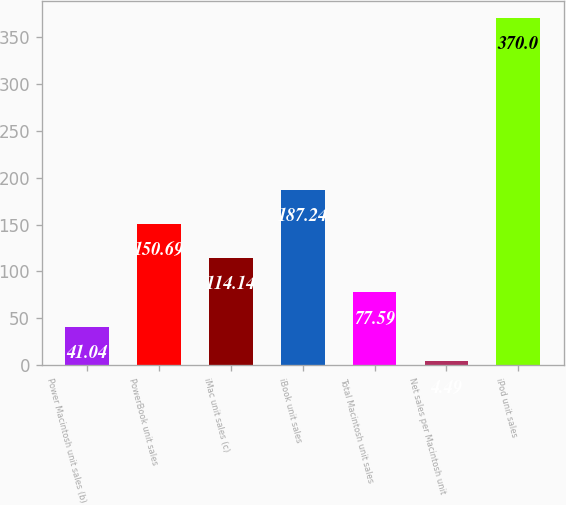Convert chart to OTSL. <chart><loc_0><loc_0><loc_500><loc_500><bar_chart><fcel>Power Macintosh unit sales (b)<fcel>PowerBook unit sales<fcel>iMac unit sales (c)<fcel>iBook unit sales<fcel>Total Macintosh unit sales<fcel>Net sales per Macintosh unit<fcel>iPod unit sales<nl><fcel>41.04<fcel>150.69<fcel>114.14<fcel>187.24<fcel>77.59<fcel>4.49<fcel>370<nl></chart> 